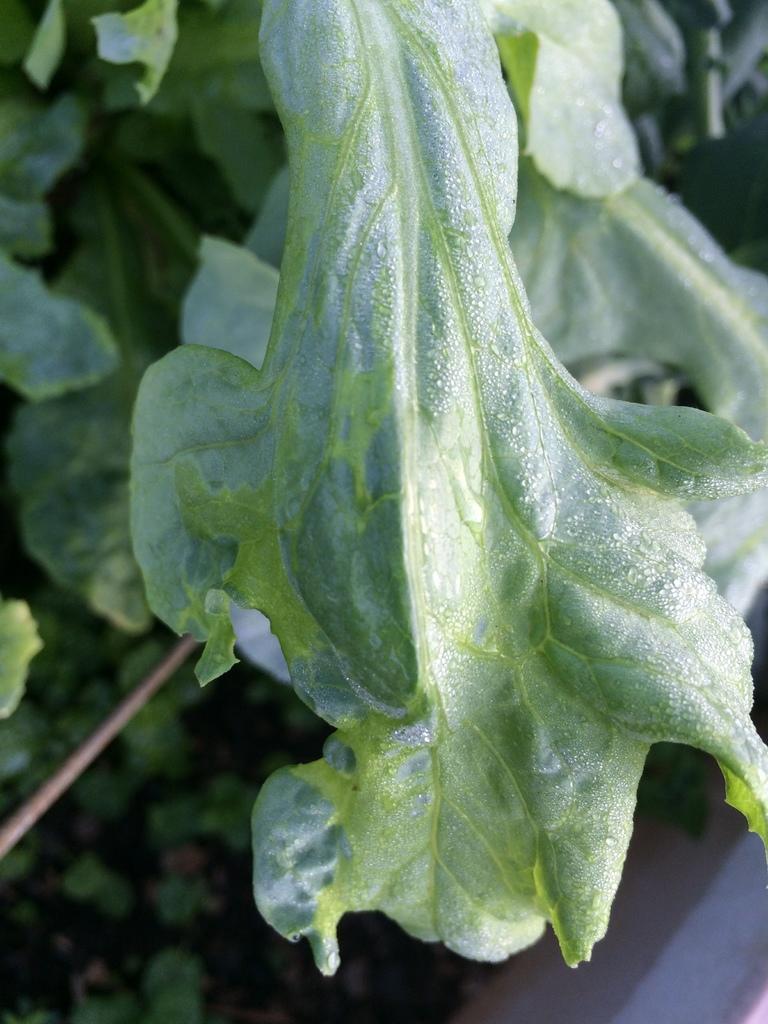Describe this image in one or two sentences. In this image we can see some leaves. 